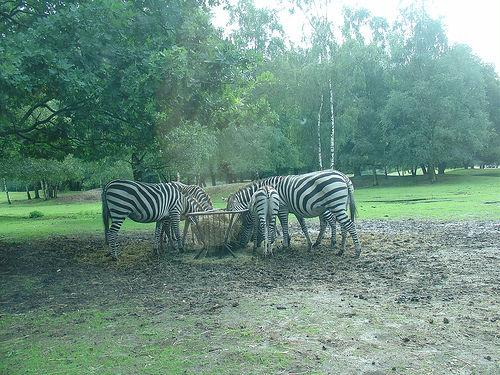These animals are mascots for what brand of gum? Please explain your reasoning. fruit stripe. Here we see zebras grazing. fruit stripe gum has a famous multicolored zebra as a mascot. 